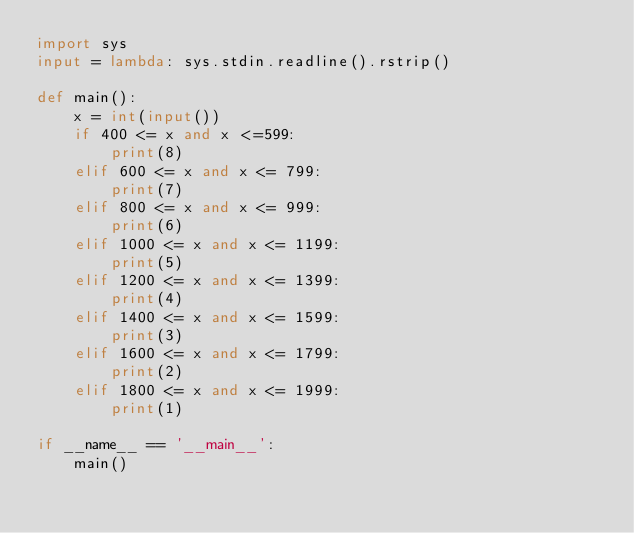<code> <loc_0><loc_0><loc_500><loc_500><_Python_>import sys
input = lambda: sys.stdin.readline().rstrip()

def main():
    x = int(input())
    if 400 <= x and x <=599:
        print(8)
    elif 600 <= x and x <= 799:
        print(7)
    elif 800 <= x and x <= 999:
        print(6)
    elif 1000 <= x and x <= 1199:
        print(5)
    elif 1200 <= x and x <= 1399:
        print(4)
    elif 1400 <= x and x <= 1599:
        print(3)
    elif 1600 <= x and x <= 1799:
        print(2)
    elif 1800 <= x and x <= 1999:
        print(1)
            
if __name__ == '__main__':
    main()</code> 